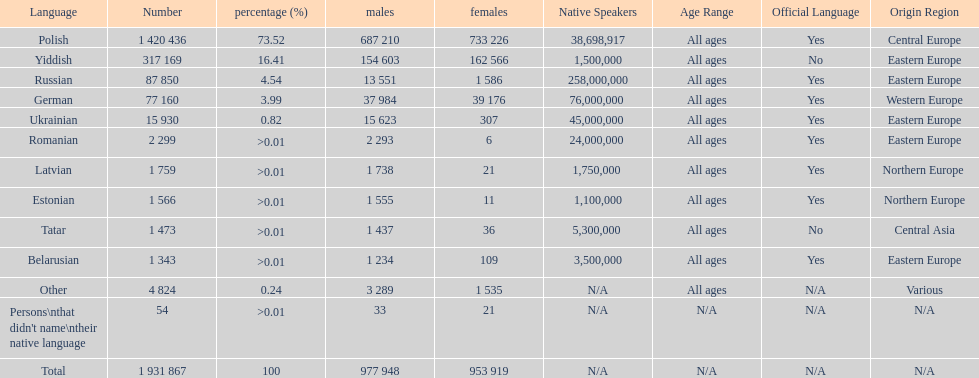The least amount of females Romanian. 